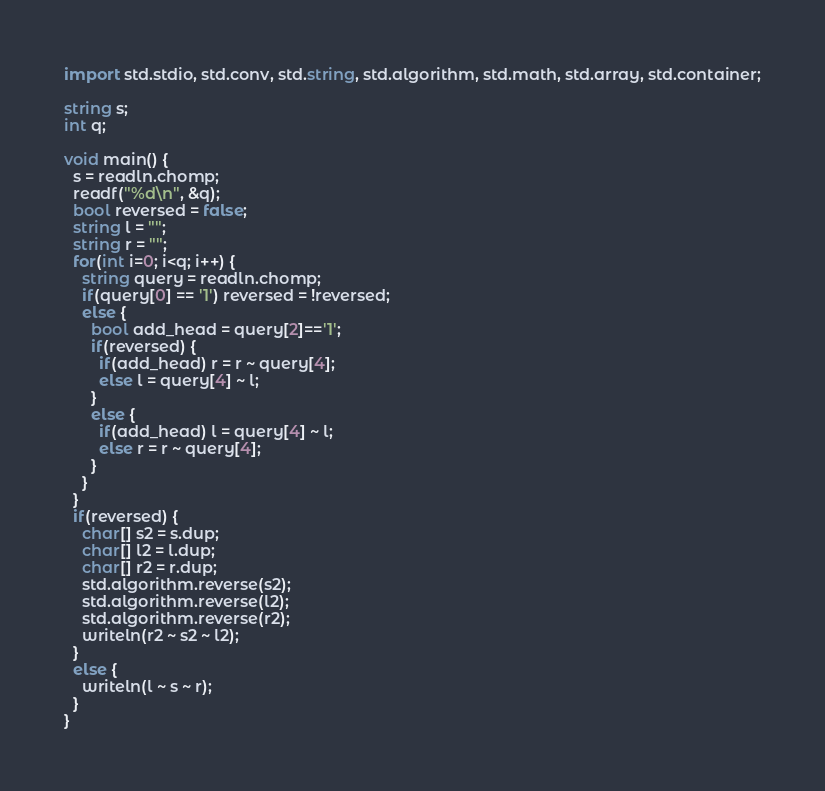<code> <loc_0><loc_0><loc_500><loc_500><_D_>import std.stdio, std.conv, std.string, std.algorithm, std.math, std.array, std.container;

string s;
int q;

void main() {
  s = readln.chomp;
  readf("%d\n", &q);
  bool reversed = false;
  string l = "";
  string r = "";
  for(int i=0; i<q; i++) {
    string query = readln.chomp;
    if(query[0] == '1') reversed = !reversed;
    else {
      bool add_head = query[2]=='1';
      if(reversed) {
        if(add_head) r = r ~ query[4];
        else l = query[4] ~ l;
      }
      else {
        if(add_head) l = query[4] ~ l;
        else r = r ~ query[4];
      }
    }
  }
  if(reversed) {
    char[] s2 = s.dup;
    char[] l2 = l.dup;
    char[] r2 = r.dup;
    std.algorithm.reverse(s2);
    std.algorithm.reverse(l2);
    std.algorithm.reverse(r2);
    writeln(r2 ~ s2 ~ l2);
  }
  else {
    writeln(l ~ s ~ r);
  }
}

</code> 